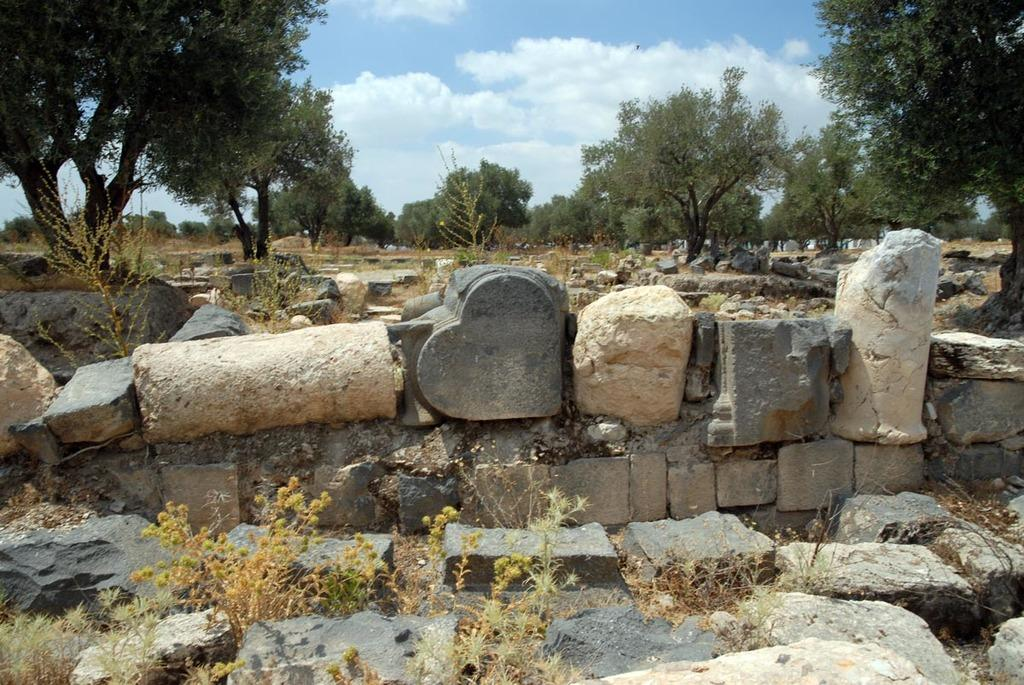What type of natural elements can be seen in the image? There are rocks, trees, and plants visible in the image. What is visible in the background of the image? The sky is visible in the background of the image. Can you see a kitty playing with a suit in the image? There is no kitty or suit present in the image. Are there any cacti visible in the image? There is no mention of cacti in the provided facts, so we cannot determine if they are present in the image. 